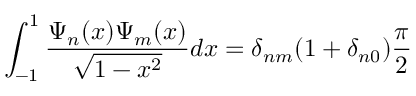<formula> <loc_0><loc_0><loc_500><loc_500>\int _ { - 1 } ^ { 1 } \frac { \Psi _ { n } ( x ) \Psi _ { m } ( x ) } { \sqrt { 1 - x ^ { 2 } } } d x = \delta _ { n m } ( 1 + \delta _ { n 0 } ) \frac { \pi } { 2 }</formula> 